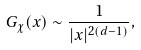<formula> <loc_0><loc_0><loc_500><loc_500>G _ { \chi } ( x ) \sim \frac { 1 } { | x | ^ { 2 ( d - 1 ) } } ,</formula> 